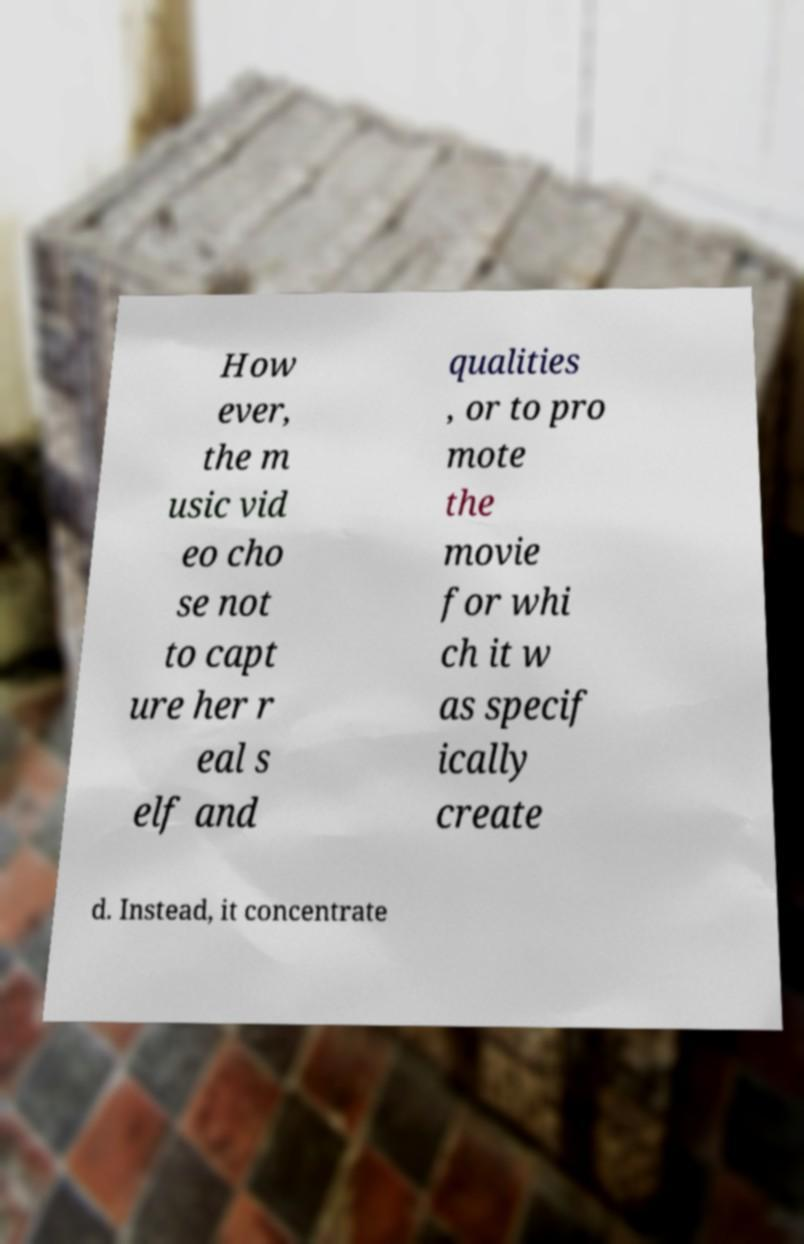I need the written content from this picture converted into text. Can you do that? How ever, the m usic vid eo cho se not to capt ure her r eal s elf and qualities , or to pro mote the movie for whi ch it w as specif ically create d. Instead, it concentrate 